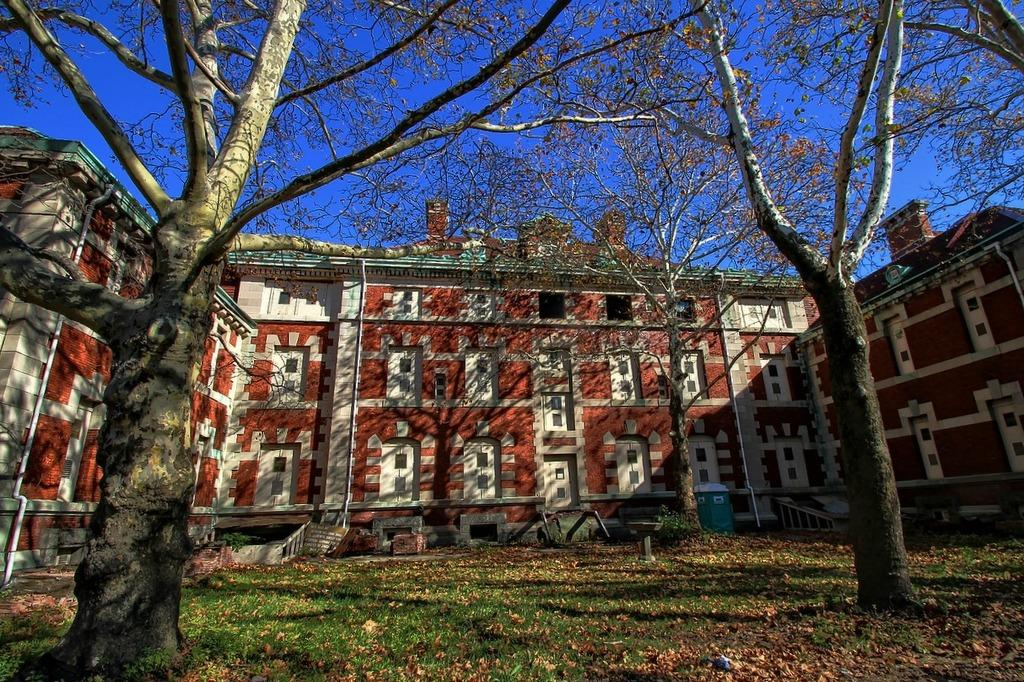What type of vegetation can be seen in the image? There are trees in the image. What type of man-made structures are present in the image? There are buildings in the image. What feature can be seen on the stairs or pathways in the image? Railings are present in the image. What object is used for waste disposal in the image? A dustbin is visible in the image. What type of ground surface is at the bottom of the image? There is grass at the bottom of the image. What additional detail can be observed on the grass surface? Dried leaves are on the surface at the bottom of the image. What is visible at the top of the image? The sky is visible at the top of the image. What type of ink is used to write on the van in the image? There is no van present in the image, so the question about ink is not applicable. 